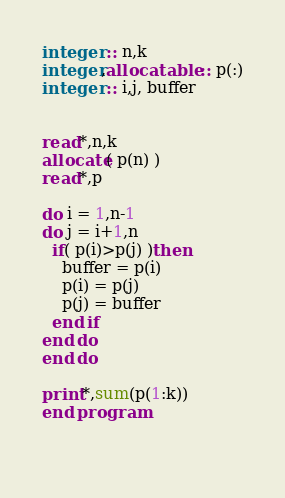Convert code to text. <code><loc_0><loc_0><loc_500><loc_500><_FORTRAN_>integer :: n,k
integer,allocatable :: p(:)
integer :: i,j, buffer


read*,n,k
allocate( p(n) )
read*,p

do i = 1,n-1
do j = i+1,n
  if( p(i)>p(j) )then
    buffer = p(i)
    p(i) = p(j)
    p(j) = buffer
  end if
end do
end do

print*,sum(p(1:k))
end program

    </code> 